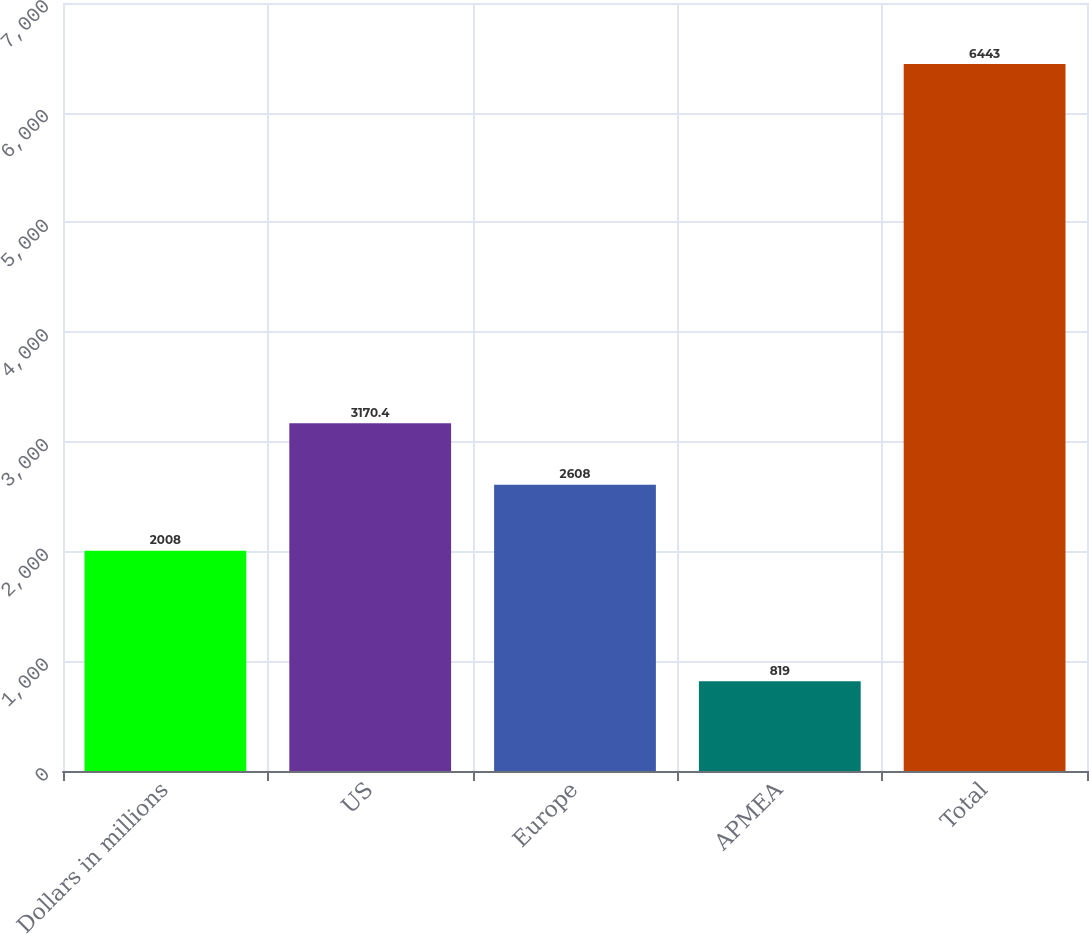<chart> <loc_0><loc_0><loc_500><loc_500><bar_chart><fcel>Dollars in millions<fcel>US<fcel>Europe<fcel>APMEA<fcel>Total<nl><fcel>2008<fcel>3170.4<fcel>2608<fcel>819<fcel>6443<nl></chart> 